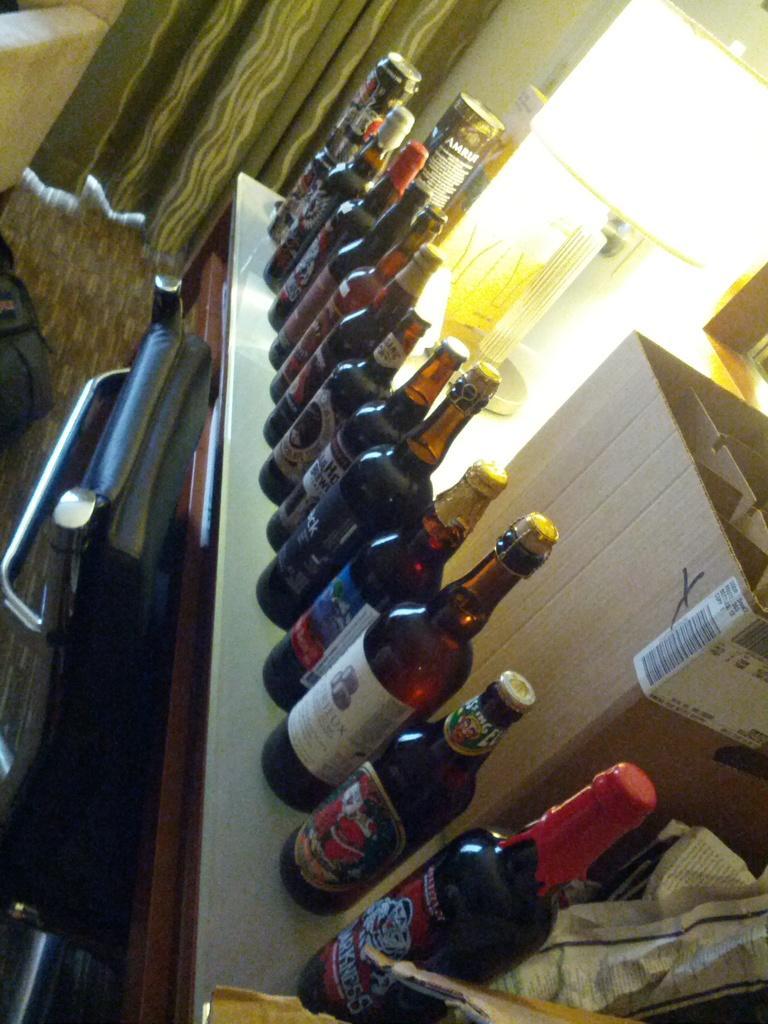In one or two sentences, can you explain what this image depicts? In this image we can see many bottles, cardboard box and table lamp on the table. In the background we can see curtains and bag. 